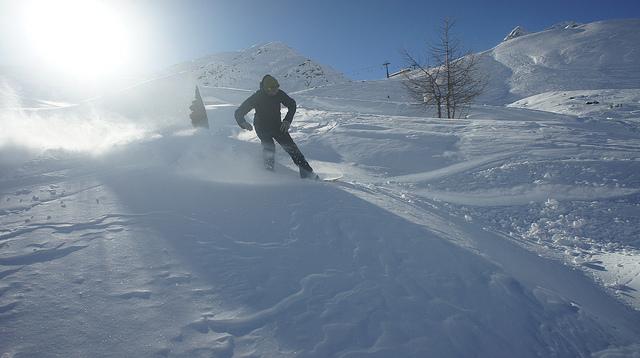Are there trees in this scene?
Concise answer only. Yes. Is there snow in this picture?
Keep it brief. Yes. What color is the snow?
Quick response, please. White. Is the man walking toward or away from the camera?
Short answer required. Toward. 